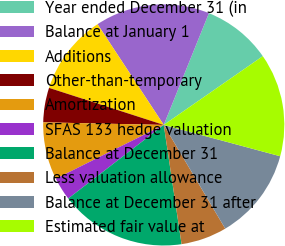Convert chart to OTSL. <chart><loc_0><loc_0><loc_500><loc_500><pie_chart><fcel>Year ended December 31 (in<fcel>Balance at January 1<fcel>Additions<fcel>Other-than-temporary<fcel>Amortization<fcel>SFAS 133 hedge valuation<fcel>Balance at December 31<fcel>Less valuation allowance<fcel>Balance at December 31 after<fcel>Estimated fair value at<nl><fcel>9.23%<fcel>15.37%<fcel>10.77%<fcel>4.63%<fcel>7.7%<fcel>3.09%<fcel>16.91%<fcel>6.16%<fcel>12.3%<fcel>13.84%<nl></chart> 